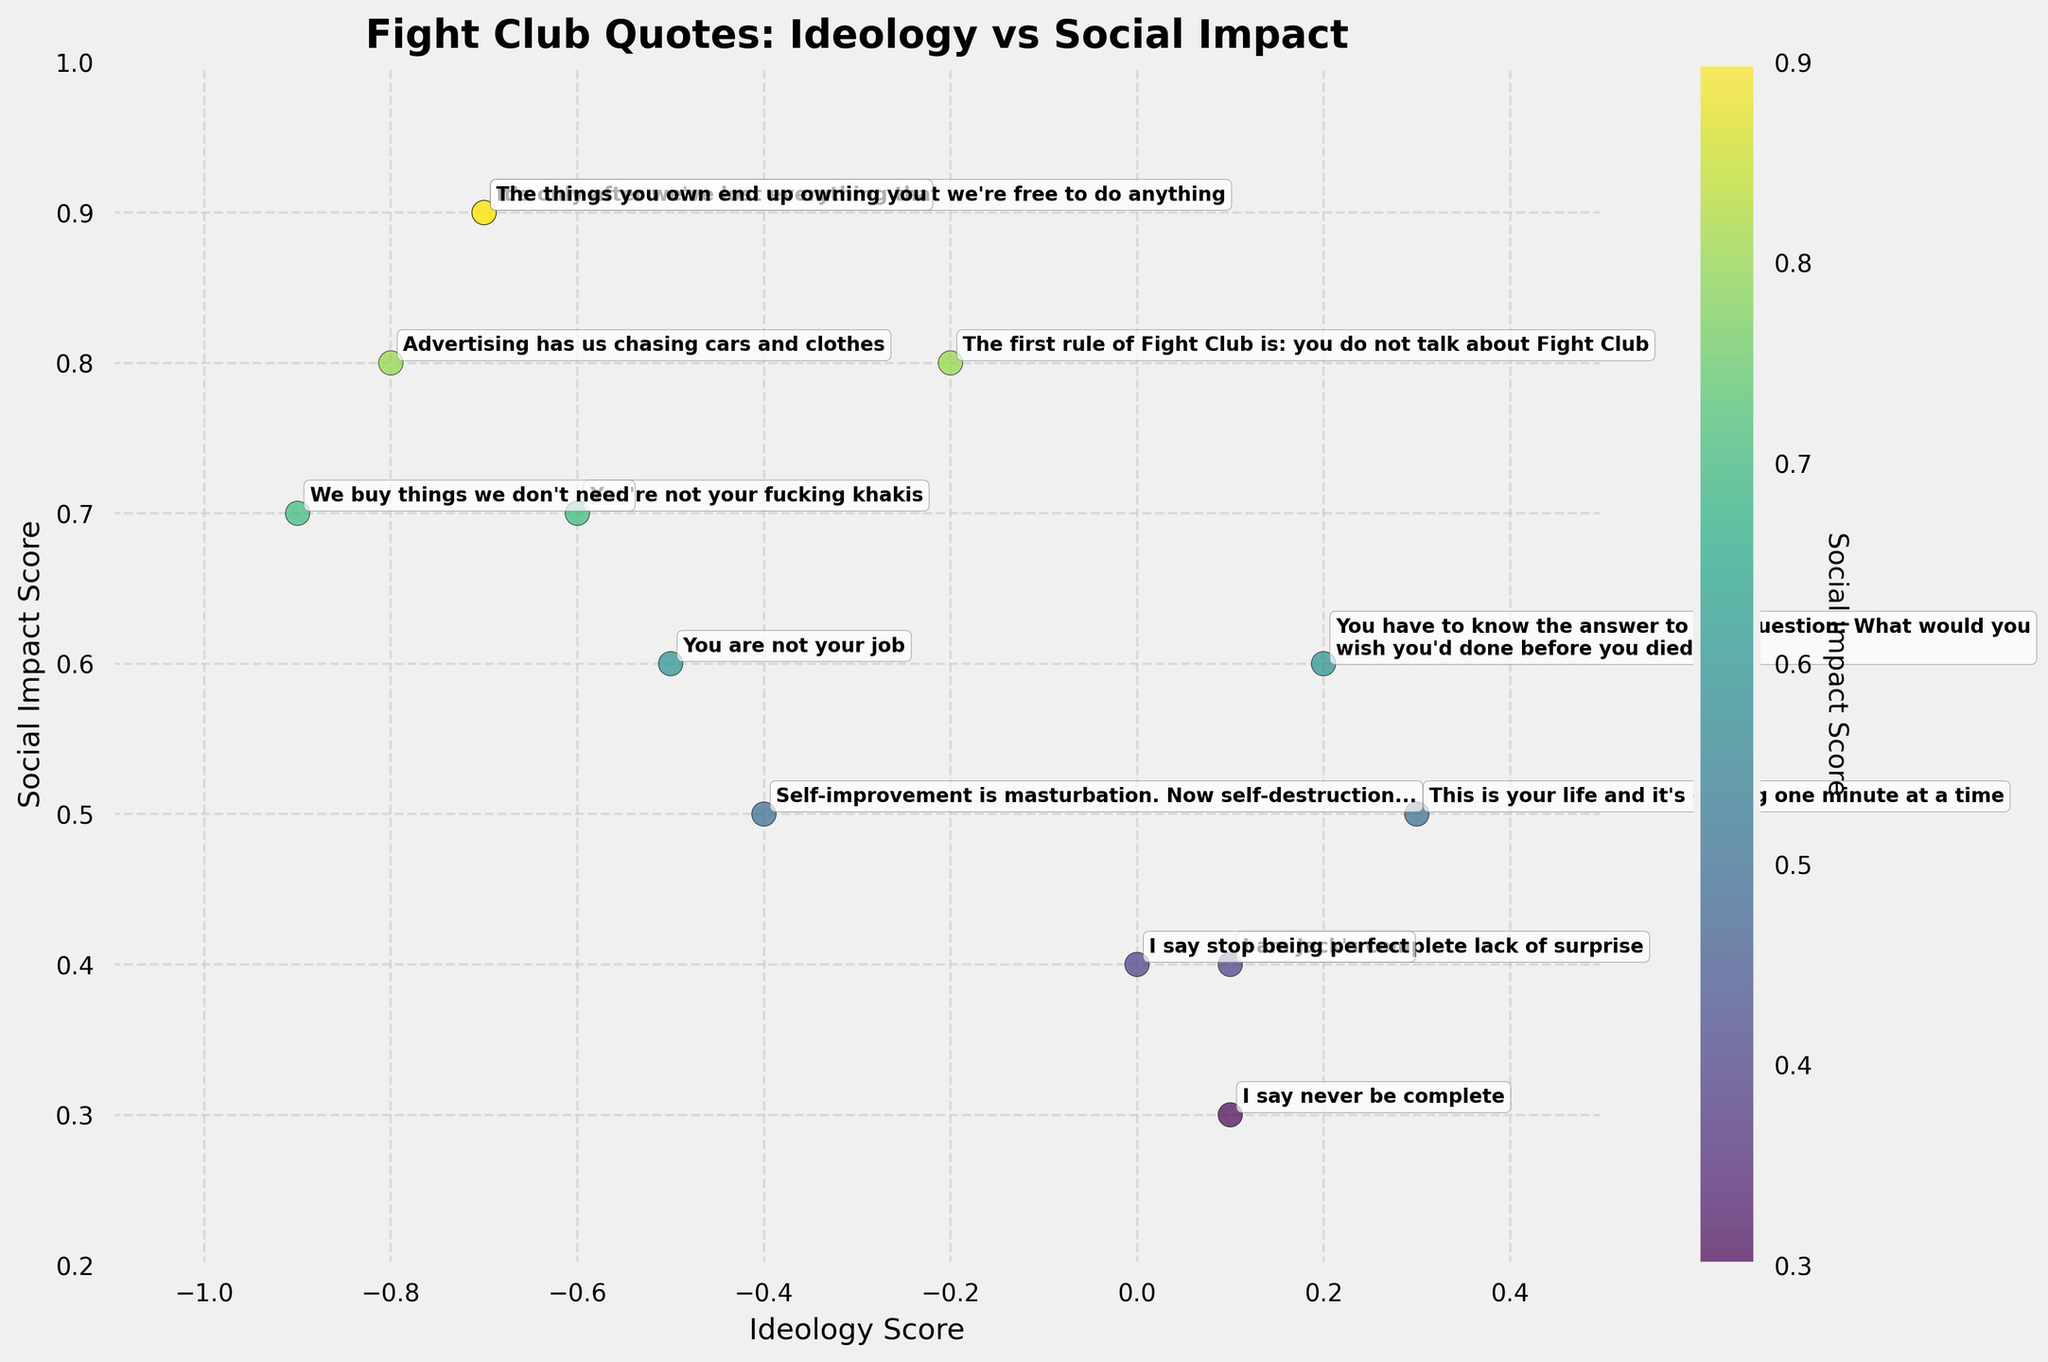What is the title of the plot? The plot's title is located at the top of the figure. It reads "Fight Club Quotes: Ideology vs Social Impact."
Answer: Fight Club Quotes: Ideology vs Social Impact How many Fight Club quotes are plotted in the figure? By counting the number of annotated quotes in the figure, we can see that there are 13 different quotes.
Answer: 13 Which quote has the highest social impact score? The quote with the highest vertical position on the y-axis has the highest social impact score. This quote is "It's only after we've lost everything that we're free to do anything" with a social impact score of 0.9.
Answer: It's only after we've lost everything that we're free to do anything What are the axis labels of the plot? The x-axis represents "Ideology Score" and the y-axis represents "Social Impact Score." These labels are found along each axis in the figure.
Answer: Ideology Score (x-axis), Social Impact Score (y-axis) Which quote has the most extreme negative ideology score? By observing the leftmost point on the x-axis, we can identify the quote "We buy things we don't need" with an ideology score of -0.9 is the most negative.
Answer: We buy things we don’t need What is the average social impact score of the quotes plotted? To find the average social impact score, sum all individual social impact scores and divide by the total number of quotes. The scores are: 0.8, 0.6, 0.4, 0.9, 0.7, 0.5, 0.8, 0.7, 0.9, 0.6, 0.5, 0.3, 0.4. The sum is 8.1, and 8.1/13 equals approximately 0.623.
Answer: Approximately 0.623 Which quote lies at the intersection or closest to the (0, 0) point on the plot? By identifying the point closest to the origin (0, 0), we determine that "I say stop being perfect" with scores (0.0, 0.4) is the closest.
Answer: I say stop being perfect Which quote has the highest ideology score and what is its value? The quote with the highest horizontal position on the x-axis is "You have to know the answer to this question: What would you wish you'd done before you died?" with an ideology score of 0.2.
Answer: You have to know the answer to this question: What would you wish you'd done before you died?, 0.2 